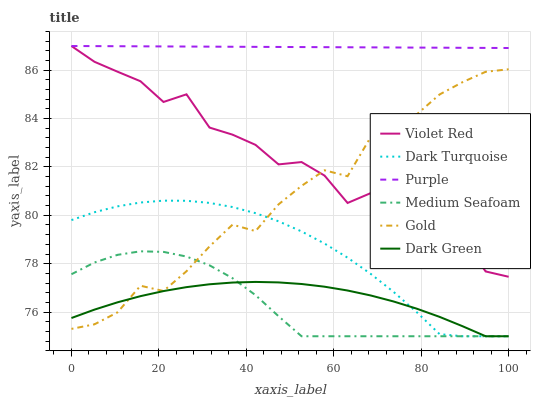Does Medium Seafoam have the minimum area under the curve?
Answer yes or no. Yes. Does Purple have the maximum area under the curve?
Answer yes or no. Yes. Does Gold have the minimum area under the curve?
Answer yes or no. No. Does Gold have the maximum area under the curve?
Answer yes or no. No. Is Purple the smoothest?
Answer yes or no. Yes. Is Violet Red the roughest?
Answer yes or no. Yes. Is Gold the smoothest?
Answer yes or no. No. Is Gold the roughest?
Answer yes or no. No. Does Gold have the lowest value?
Answer yes or no. No. Does Gold have the highest value?
Answer yes or no. No. Is Dark Turquoise less than Violet Red?
Answer yes or no. Yes. Is Purple greater than Dark Turquoise?
Answer yes or no. Yes. Does Dark Turquoise intersect Violet Red?
Answer yes or no. No. 